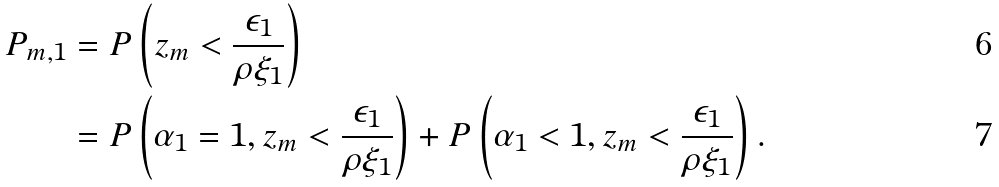Convert formula to latex. <formula><loc_0><loc_0><loc_500><loc_500>P _ { m , 1 } & = P \left ( z _ { m } < \frac { \epsilon _ { 1 } } { \rho \xi _ { 1 } } \right ) \\ & = P \left ( \alpha _ { 1 } = 1 , z _ { m } < \frac { \epsilon _ { 1 } } { \rho \xi _ { 1 } } \right ) + P \left ( \alpha _ { 1 } < 1 , z _ { m } < \frac { \epsilon _ { 1 } } { \rho \xi _ { 1 } } \right ) .</formula> 